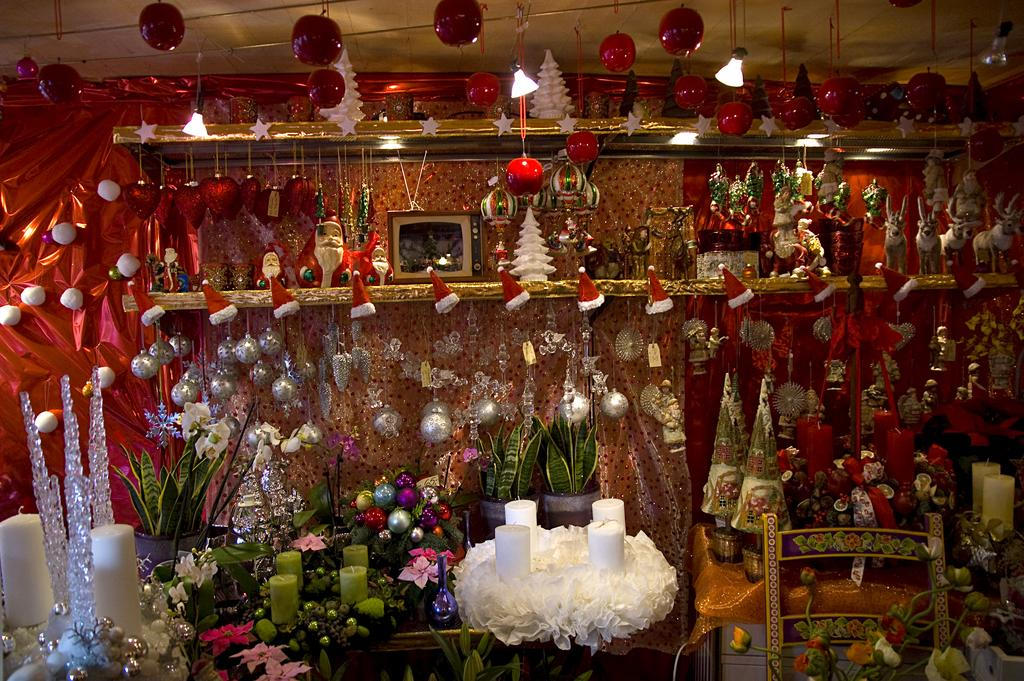What type of objects can be seen in the image? There are balls, lights, plants, Christmas hats, toys, and other objects in the image. Can you describe the lights in the image? The lights are likely decorative, as they are in the context of other holiday-themed items like Christmas hats. What type of plants are present in the image? The plants in the image are likely small and possibly artificial, given their presence alongside other holiday decorations. What type of toys can be seen in the image? The toys in the image are likely small and related to the holiday theme, such as toy reindeer or snowmen. What type of medical procedure is being performed on the wrench in the image? There is no wrench present in the image, and therefore no medical procedure can be observed. 